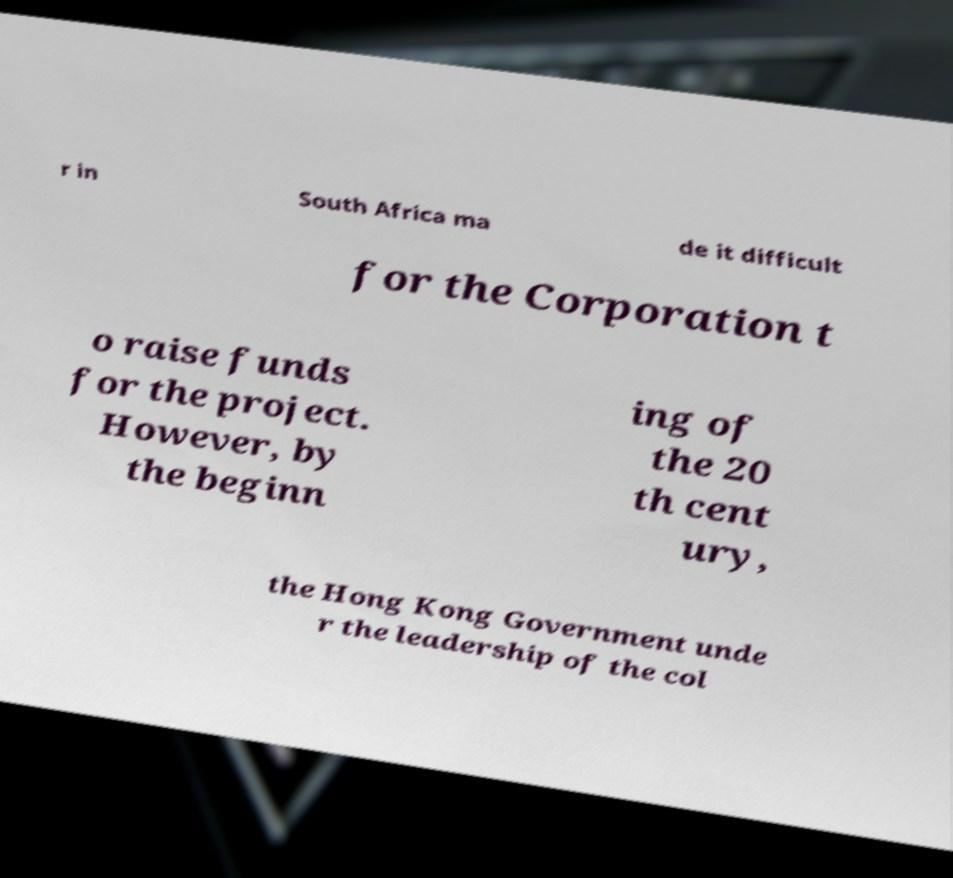I need the written content from this picture converted into text. Can you do that? r in South Africa ma de it difficult for the Corporation t o raise funds for the project. However, by the beginn ing of the 20 th cent ury, the Hong Kong Government unde r the leadership of the col 